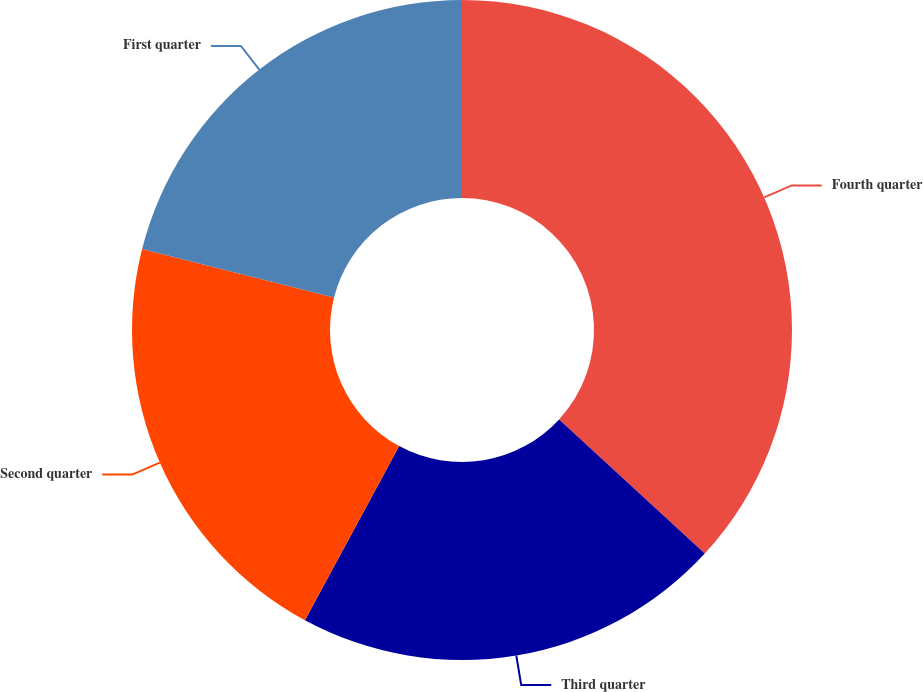Convert chart to OTSL. <chart><loc_0><loc_0><loc_500><loc_500><pie_chart><fcel>Fourth quarter<fcel>Third quarter<fcel>Second quarter<fcel>First quarter<nl><fcel>36.84%<fcel>21.05%<fcel>21.05%<fcel>21.05%<nl></chart> 